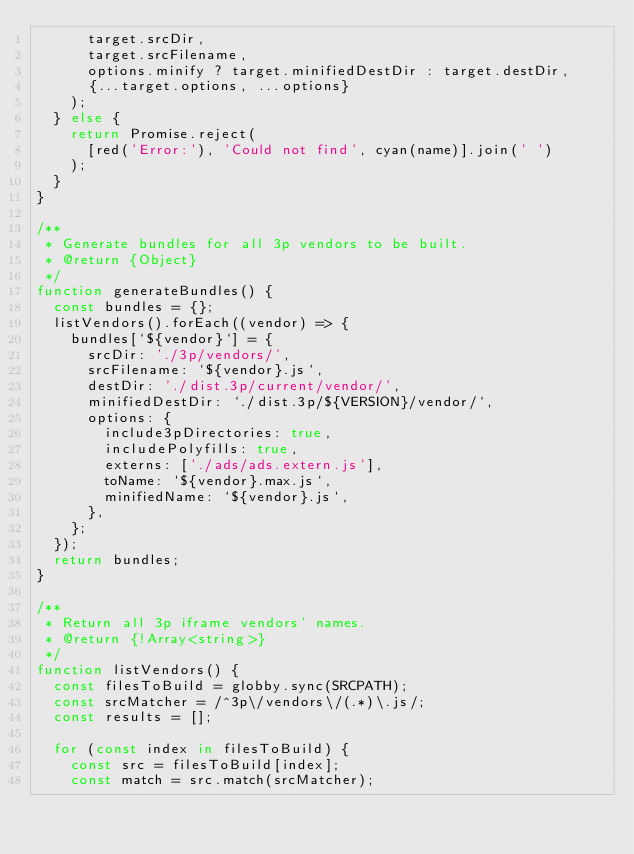<code> <loc_0><loc_0><loc_500><loc_500><_JavaScript_>      target.srcDir,
      target.srcFilename,
      options.minify ? target.minifiedDestDir : target.destDir,
      {...target.options, ...options}
    );
  } else {
    return Promise.reject(
      [red('Error:'), 'Could not find', cyan(name)].join(' ')
    );
  }
}

/**
 * Generate bundles for all 3p vendors to be built.
 * @return {Object}
 */
function generateBundles() {
  const bundles = {};
  listVendors().forEach((vendor) => {
    bundles[`${vendor}`] = {
      srcDir: './3p/vendors/',
      srcFilename: `${vendor}.js`,
      destDir: './dist.3p/current/vendor/',
      minifiedDestDir: `./dist.3p/${VERSION}/vendor/`,
      options: {
        include3pDirectories: true,
        includePolyfills: true,
        externs: ['./ads/ads.extern.js'],
        toName: `${vendor}.max.js`,
        minifiedName: `${vendor}.js`,
      },
    };
  });
  return bundles;
}

/**
 * Return all 3p iframe vendors' names.
 * @return {!Array<string>}
 */
function listVendors() {
  const filesToBuild = globby.sync(SRCPATH);
  const srcMatcher = /^3p\/vendors\/(.*)\.js/;
  const results = [];

  for (const index in filesToBuild) {
    const src = filesToBuild[index];
    const match = src.match(srcMatcher);</code> 